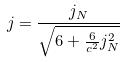Convert formula to latex. <formula><loc_0><loc_0><loc_500><loc_500>j = \frac { j _ { N } } { \sqrt { 6 + \frac { 6 } { c ^ { 2 } } j _ { N } ^ { 2 } } }</formula> 